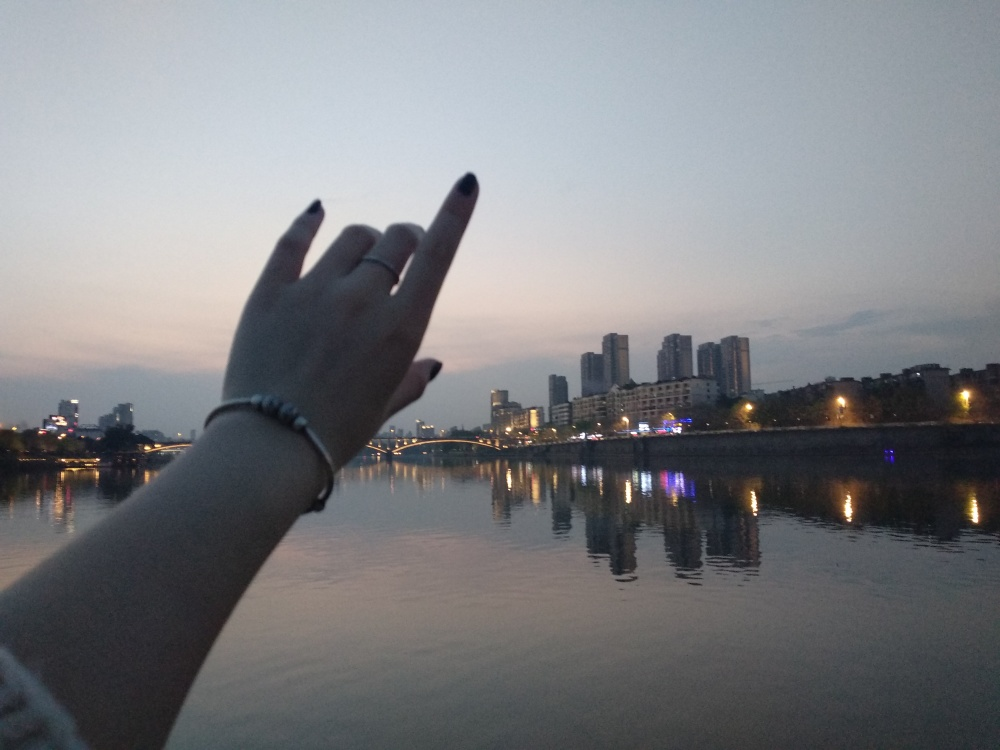How would you describe the colors in the image? The image features a soft pastel color palette, with gentle shades of blue and purple in the twilight sky. The cityscape is illuminated by warm yellow and white lights that reflect beautifully on the calm river surface, creating a serene and somewhat dreamy atmosphere. 